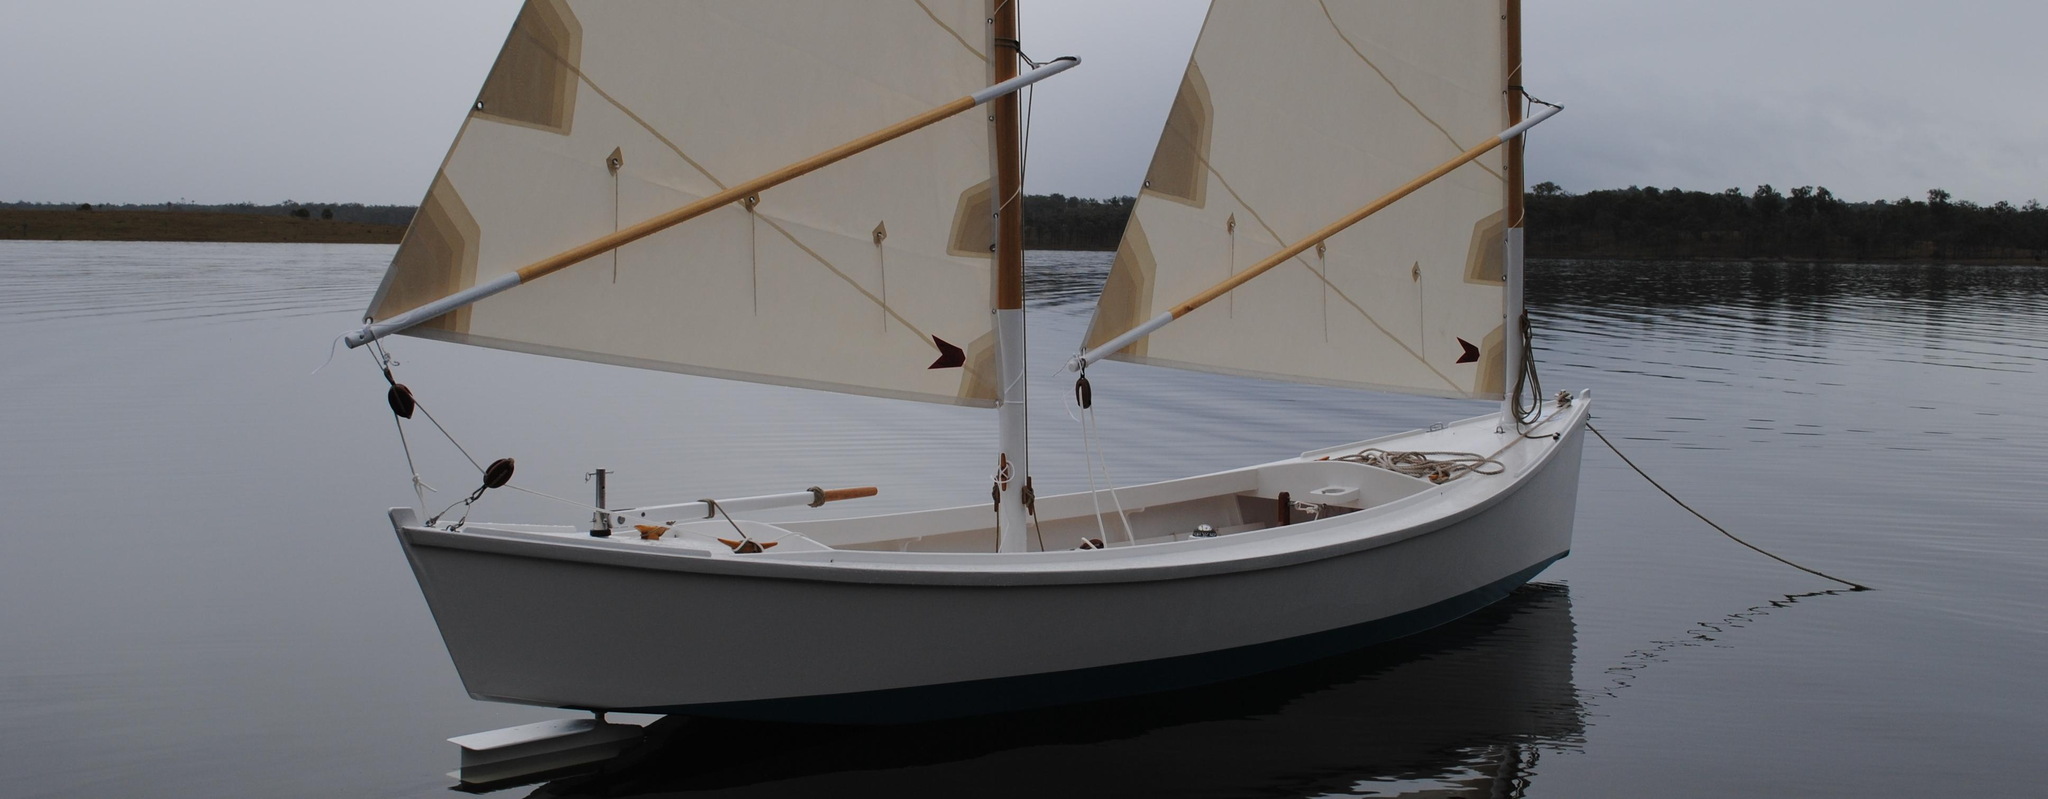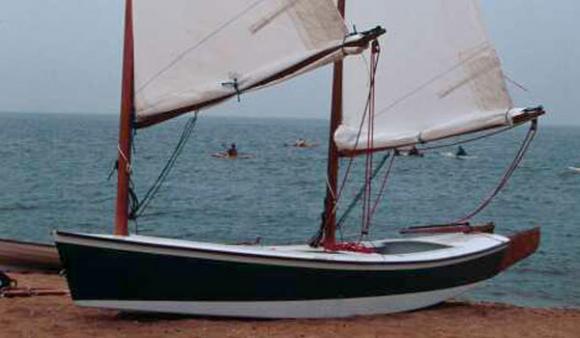The first image is the image on the left, the second image is the image on the right. For the images displayed, is the sentence "the image pair has a boat with two raised sails" factually correct? Answer yes or no. Yes. The first image is the image on the left, the second image is the image on the right. For the images shown, is this caption "Each sailboat has two white sails." true? Answer yes or no. Yes. 